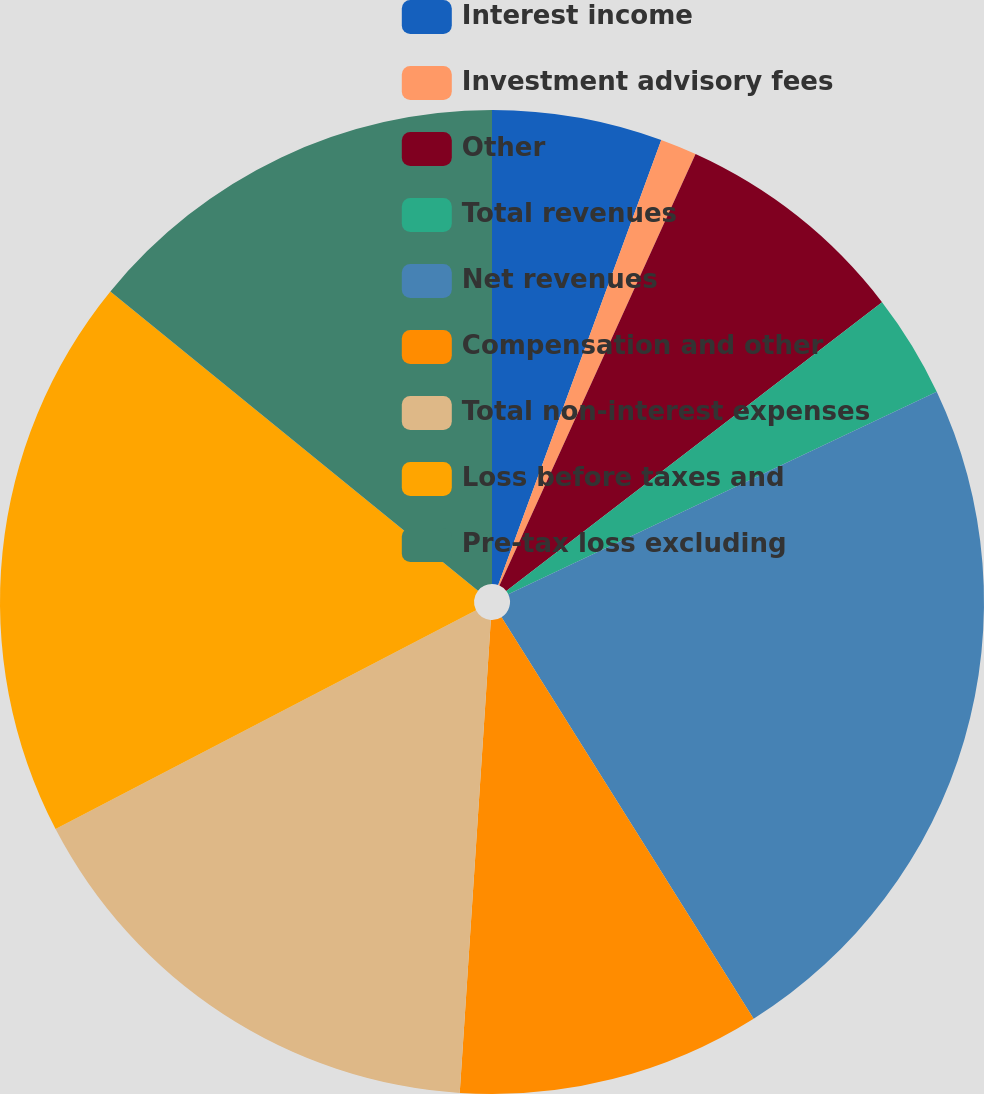Convert chart to OTSL. <chart><loc_0><loc_0><loc_500><loc_500><pie_chart><fcel>Interest income<fcel>Investment advisory fees<fcel>Other<fcel>Total revenues<fcel>Net revenues<fcel>Compensation and other<fcel>Total non-interest expenses<fcel>Loss before taxes and<fcel>Pre-tax loss excluding<nl><fcel>5.59%<fcel>1.2%<fcel>7.78%<fcel>3.4%<fcel>23.11%<fcel>9.97%<fcel>16.32%<fcel>18.51%<fcel>14.13%<nl></chart> 